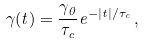<formula> <loc_0><loc_0><loc_500><loc_500>\gamma ( t ) = \frac { \gamma _ { 0 } } { \tau _ { c } } e ^ { - | t | / \tau _ { c } } \, ,</formula> 